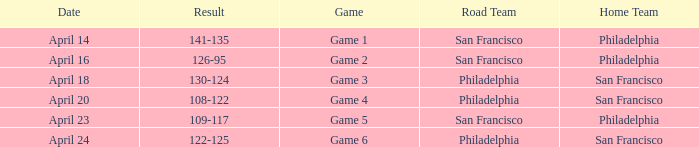What was the result of the April 16 game? 126-95. 